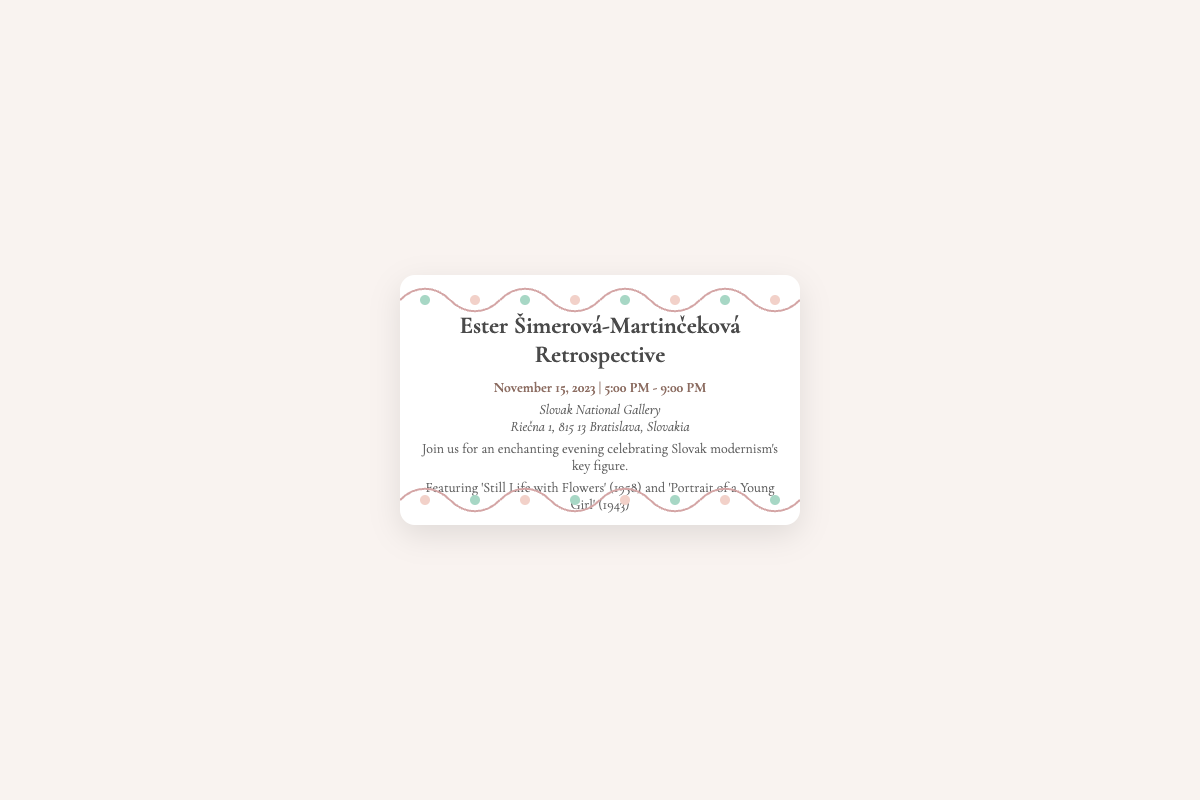What is the date of the retrospective? The date is specified in the document, which mentions the event will take place on November 15, 2023.
Answer: November 15, 2023 What time does the exhibition start? The document indicates that the exhibition starts at 5:00 PM.
Answer: 5:00 PM Where is the event located? The location is provided in the document, stating it is at the Slovak National Gallery.
Answer: Slovak National Gallery What are two key artworks featured in the exhibition? The document lists 'Still Life with Flowers' and 'Portrait of a Young Girl' as key artworks.
Answer: 'Still Life with Flowers' and 'Portrait of a Young Girl' What type of event is this invitation for? The document describes the event as a retrospective, which is a specific type of exhibition.
Answer: Retrospective What is the ending time of the event? The document states the event will end at 9:00 PM.
Answer: 9:00 PM Which artistic movement is Ester Šimerová-Martinčeková associated with? The document references her as a key figure in Slovak modernism, indicating her artistic movement.
Answer: Slovak modernism 